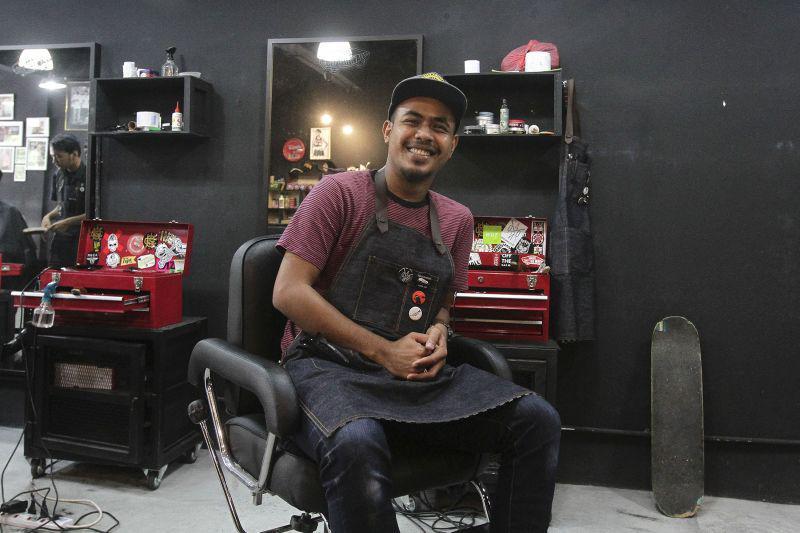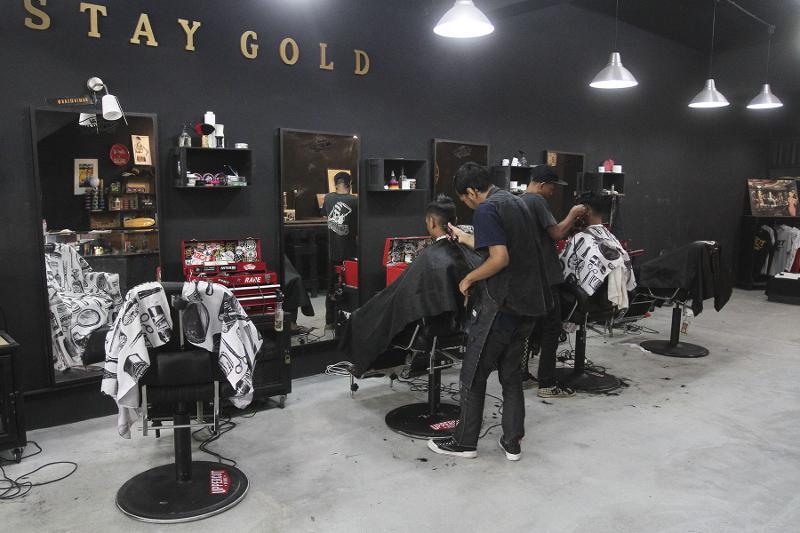The first image is the image on the left, the second image is the image on the right. Analyze the images presented: Is the assertion "One image clearly shows one barber posed with one barber chair." valid? Answer yes or no. Yes. The first image is the image on the left, the second image is the image on the right. Given the left and right images, does the statement "there is a door in one of the images" hold true? Answer yes or no. No. 